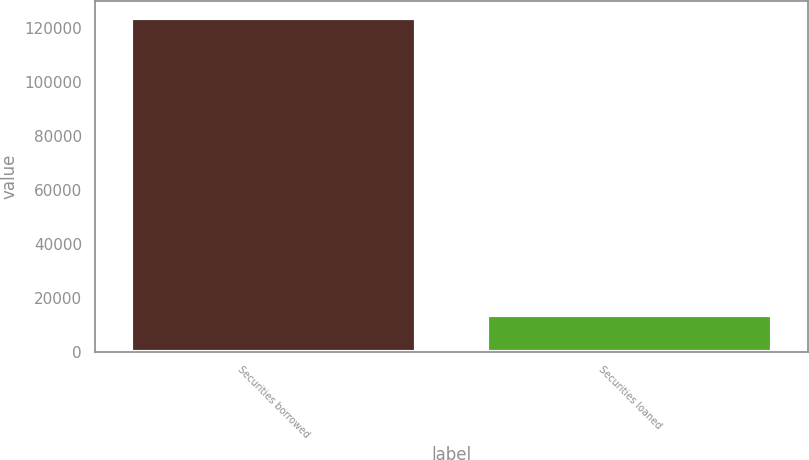<chart> <loc_0><loc_0><loc_500><loc_500><bar_chart><fcel>Securities borrowed<fcel>Securities loaned<nl><fcel>124010<fcel>13592<nl></chart> 